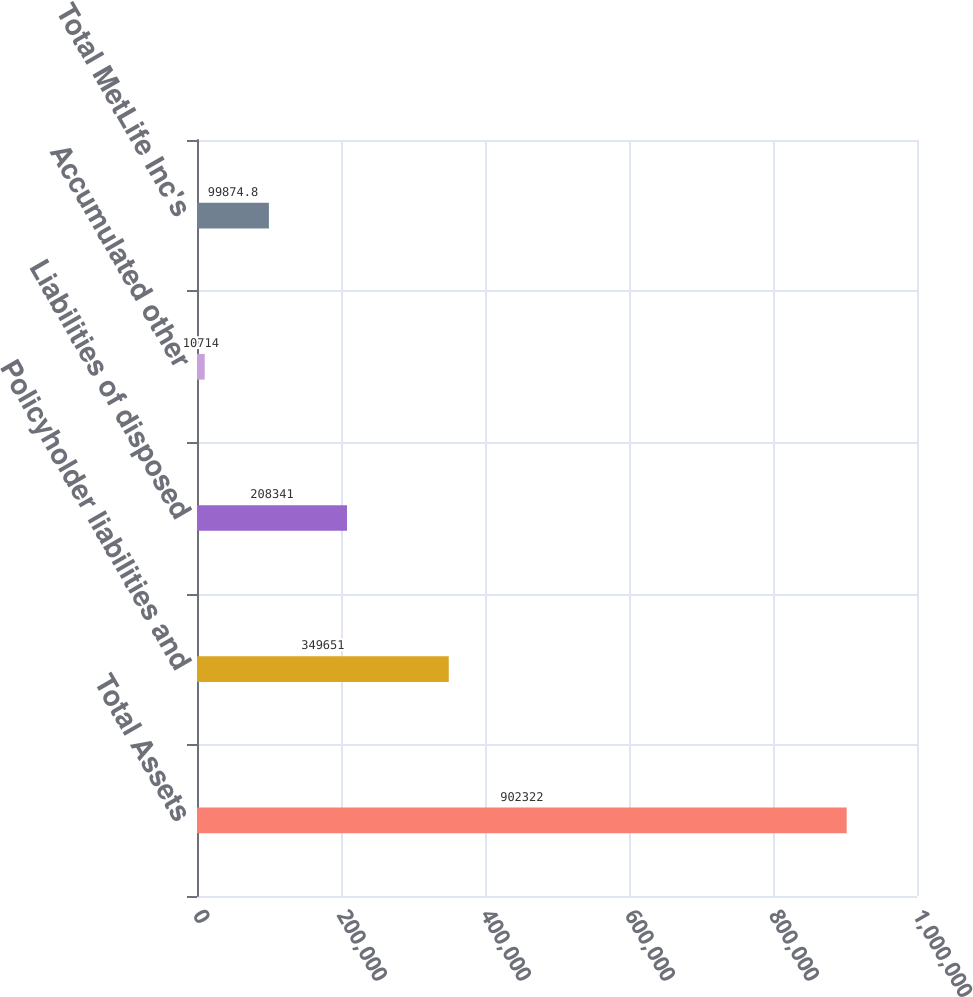Convert chart. <chart><loc_0><loc_0><loc_500><loc_500><bar_chart><fcel>Total Assets<fcel>Policyholder liabilities and<fcel>Liabilities of disposed<fcel>Accumulated other<fcel>Total MetLife Inc's<nl><fcel>902322<fcel>349651<fcel>208341<fcel>10714<fcel>99874.8<nl></chart> 